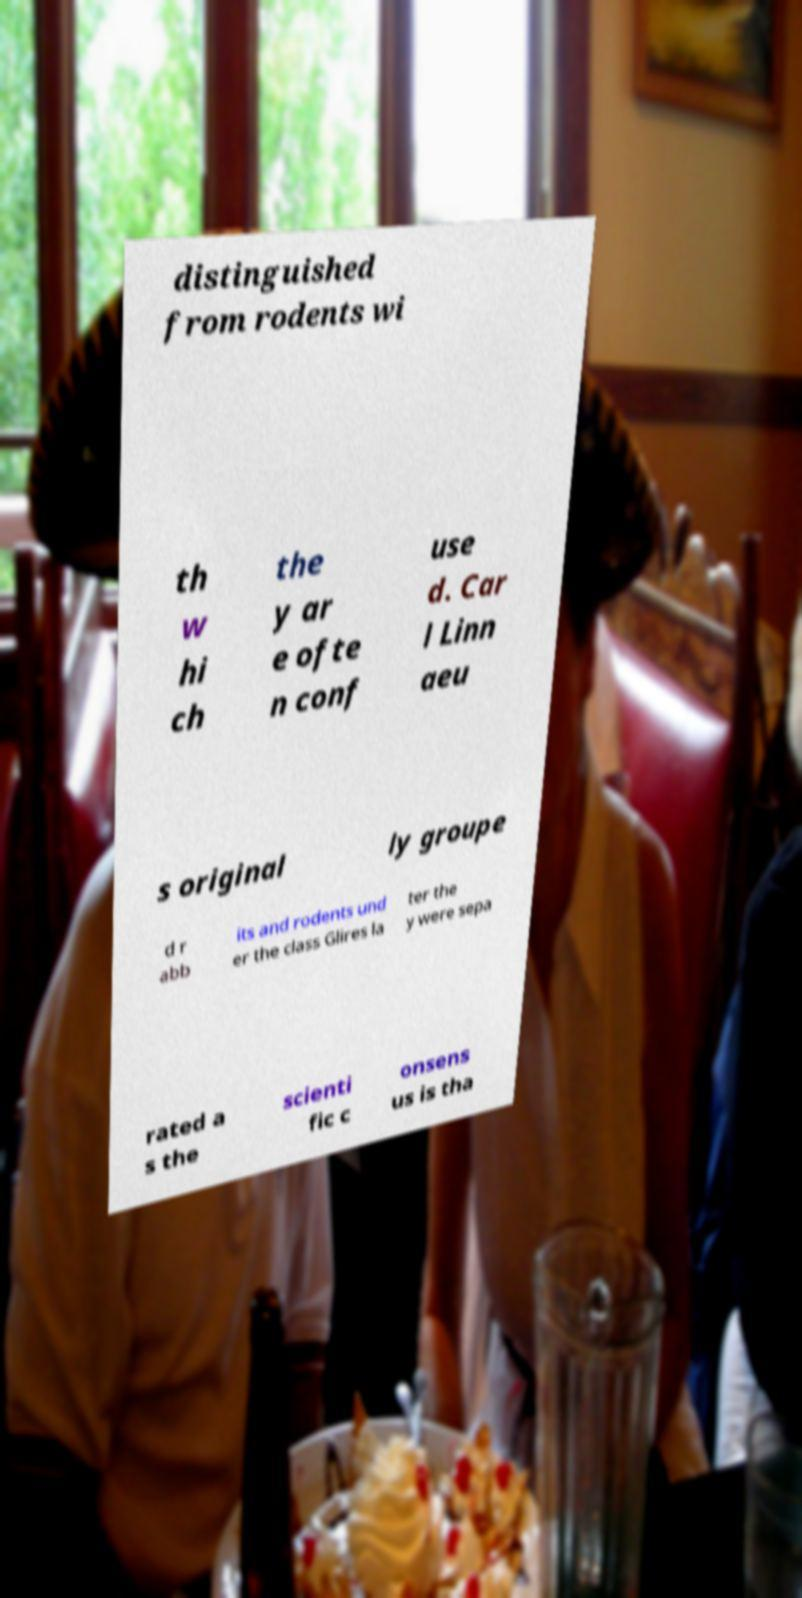There's text embedded in this image that I need extracted. Can you transcribe it verbatim? distinguished from rodents wi th w hi ch the y ar e ofte n conf use d. Car l Linn aeu s original ly groupe d r abb its and rodents und er the class Glires la ter the y were sepa rated a s the scienti fic c onsens us is tha 